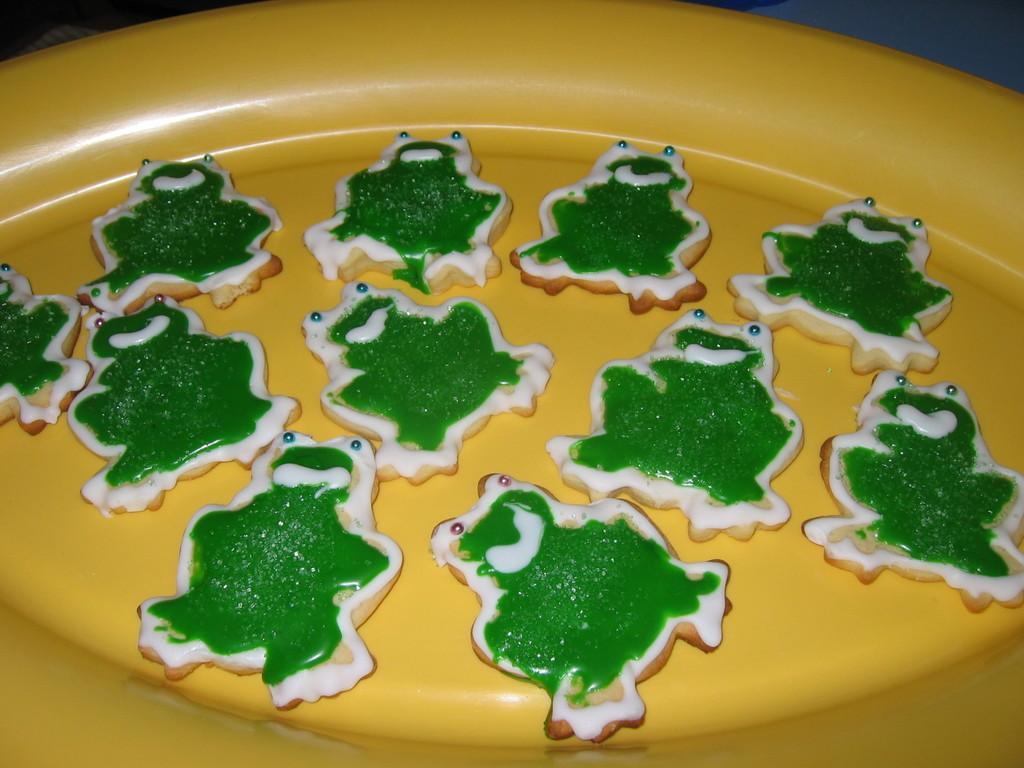Please provide a concise description of this image. In the image there is a plate. On the plate there are frog shaped cookies with cream on it. 